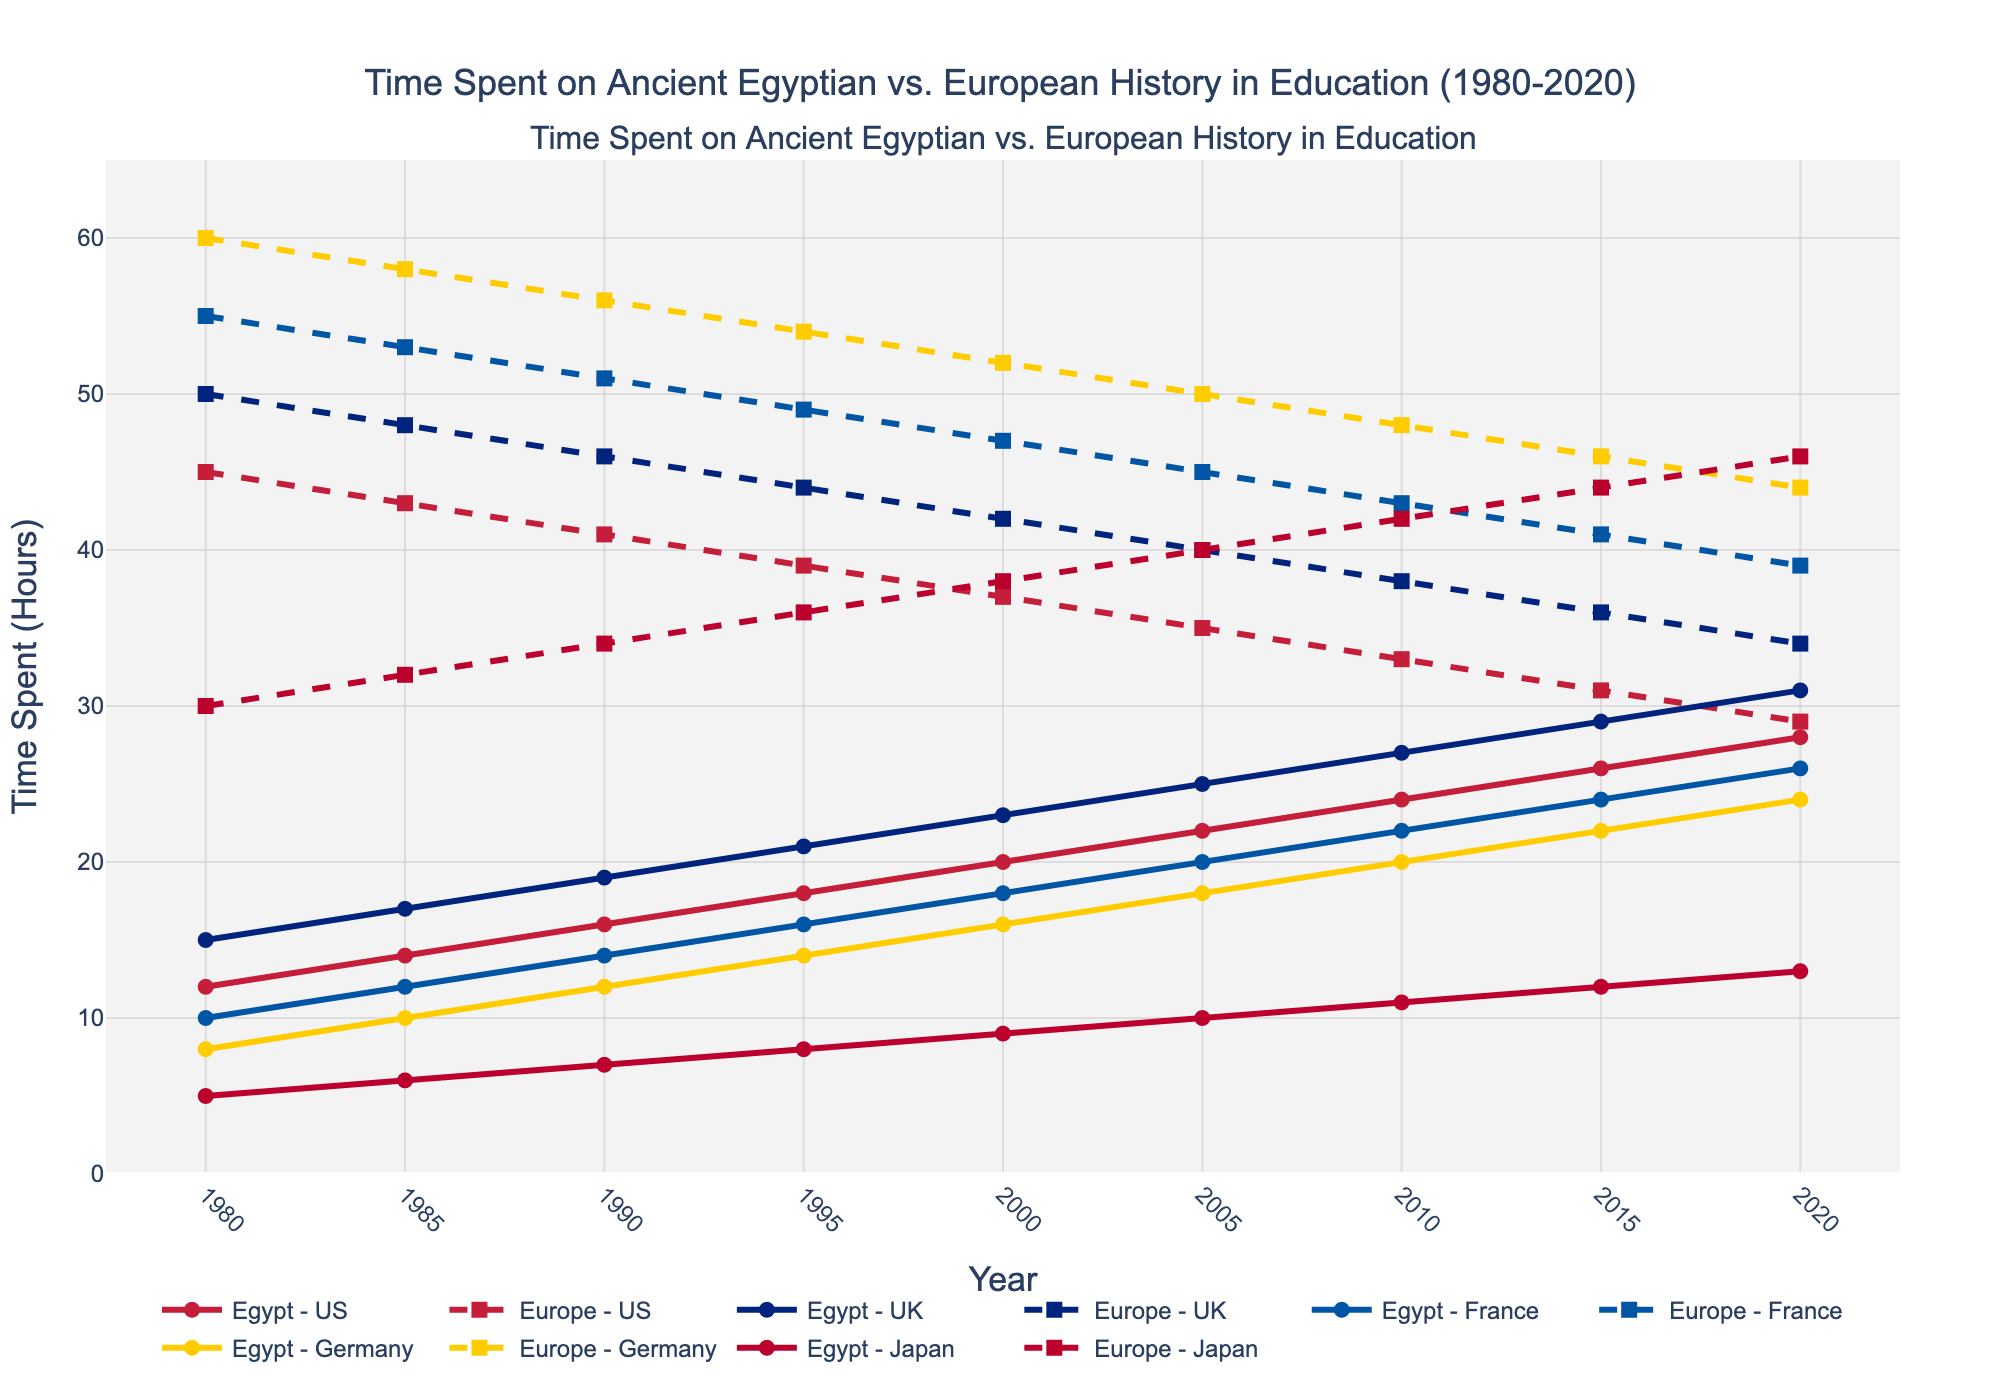What country showed the highest increase in time spent on Ancient Egyptian history from 1980 to 2020? To determine the highest increase, calculate the difference between the 2020 and 1980 values for each country. For the US, the increase is 28-12=16 hours. For the UK, it is 31-15=16 hours. For France, it is 26-10=16 hours. For Germany, it is 24-8=16 hours. For Japan, it is 13-5=8 hours. All countries except Japan had an increase of 16 hours, meaning the highest increase is shared among the US, UK, France, and Germany.
Answer: US, UK, France, Germany How does the time spent on Ancient European history in the US in 2020 compare to that in Japan? Look at the values for Ancient European history in the US and Japan in 2020. In the US, it is 29 hours, and in Japan, it is 46 hours.
Answer: Japan has more time spent Which year showed the smallest difference between time spent on Ancient Egyptian and Ancient European history in any country? To find this, calculate the absolute difference between time spent on Ancient Egyptian and Ancient European history each year for each country. The smallest difference is 2 hours in 2020 for the US (28-29).
Answer: 2020 In which country did the time spent on Ancient European history decrease the most from 1980 to 2020? Calculate the decrease for each country. In the US, the decrease is 45-29=16 hours. In the UK, it is 50-34=16 hours. In France, it is 55-39=16 hours. In Germany, it is 60-44=16 hours. In Japan, it is 30-46=-16 hours (an increase). All countries except Japan had a decrease of 16 hours, implying a tie.
Answer: US, UK, France, Germany What's the average time spent on Ancient Egyptian history in all countries in 2020? Sum the values for Ancient Egyptian history across all countries in 2020 and divide by the number of countries. The total time is 28+31+26+24+13=122. There are 5 countries, so the average is 122/5=24.4 hours.
Answer: 24.4 hours Which country spent the least time on Ancient Egyptian history in 1980, and how much was it? Look at the 1980 values for Ancient Egyptian history for each country. The least time spent was in Germany with 8 hours.
Answer: Germany, 8 hours By how many hours did the time spent on Ancient European history differ between France and Germany in 1980? Look at the 1980 values for Ancient European history for France (55 hours) and Germany (60 hours). The difference is 60-55=5 hours.
Answer: 5 hours Across all years, which country demonstrates a relatively consistent increase in time spent on Ancient Egyptian history? To determine consistency, examine the year-over-year changes for each country. All countries show a relatively consistent increase, which can be confirmed by observing their positive and smoothly increasing trends.
Answer: All countries What's the total difference in hours spent on Ancient Egyptian history between Germany and Japan in 2000? Look at the 2000 values for Ancient Egyptian history for Germany (16 hours) and Japan (9 hours). The difference is 16-9=7 hours.
Answer: 7 hours How does the trend of time spent on Ancient Egyptian history in the UK compare to that of Japan from 1980 to 2020? Observe the trend lines for both the UK and Japan. The UK shows a steady increase from 15 to 31 hours, while Japan increases from 5 to 13 hours. Both trends are upward, but the UK's increase is more significant and consistent.
Answer: UK's increase is more significant 